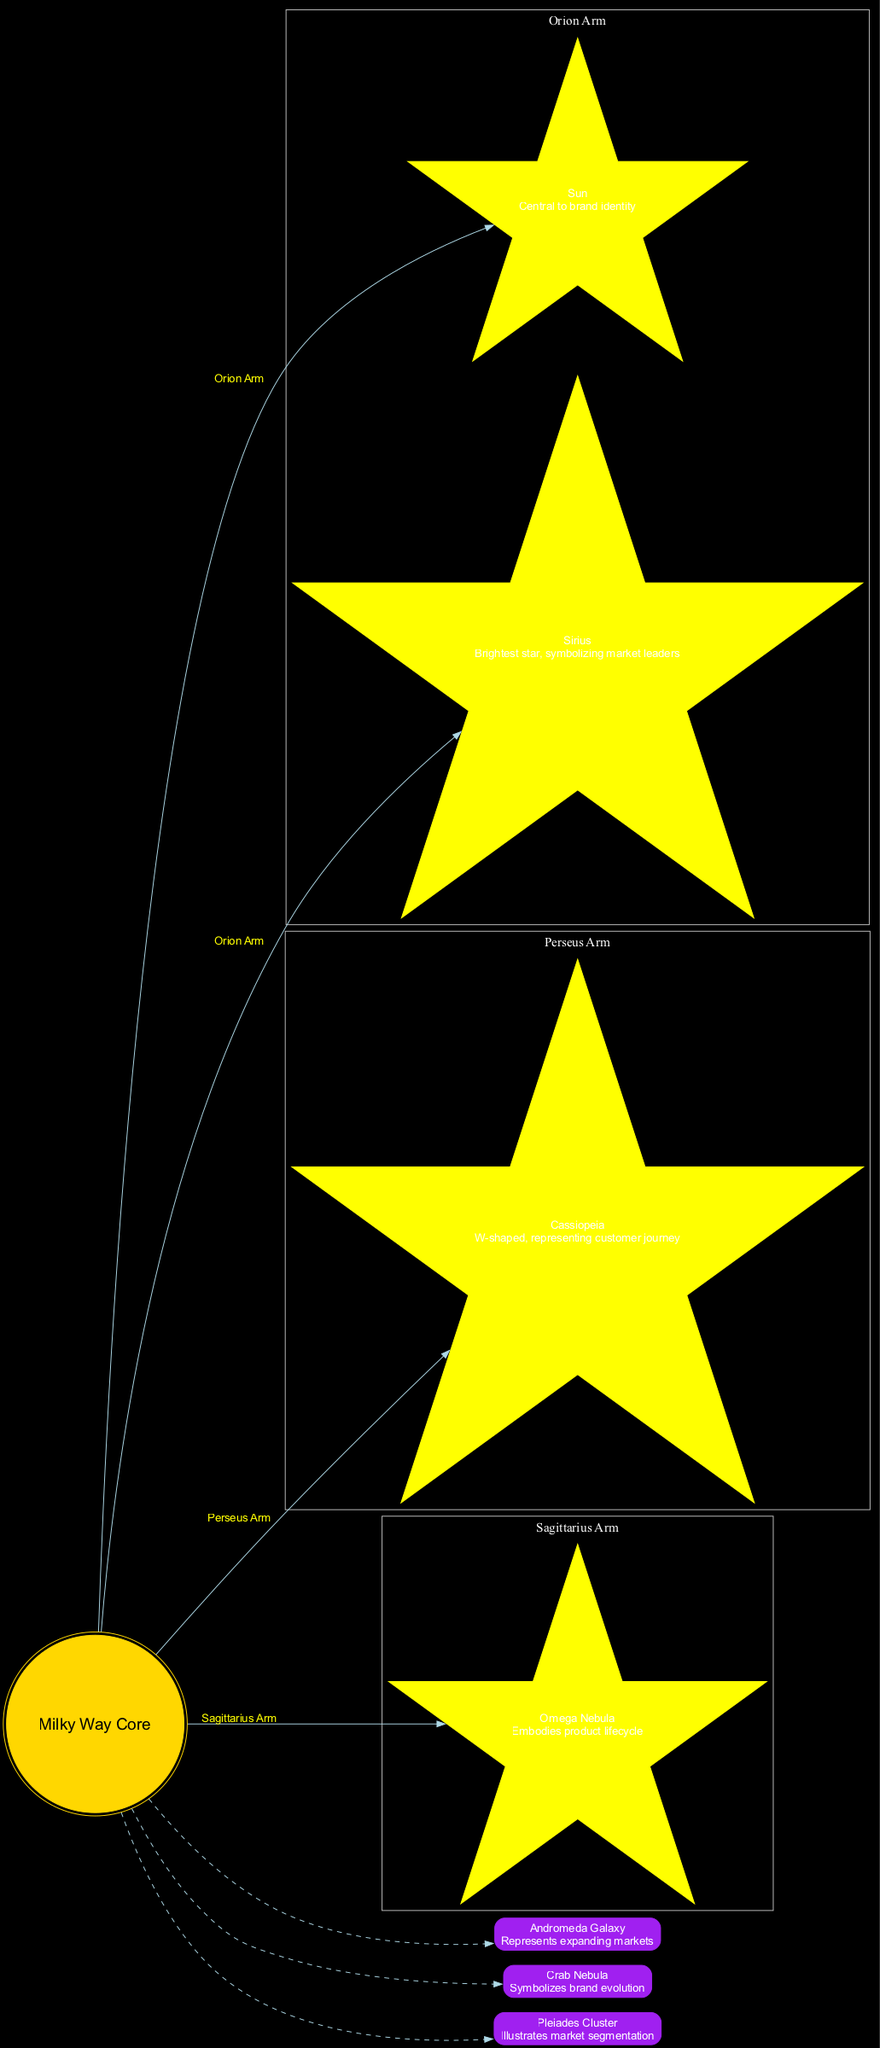What is at the center of the diagram? The diagram identifies "Milky Way Core" as the central node, explicitly labeled in a distinct style. This core serves as the focal point of the galaxy representation.
Answer: Milky Way Core How many arms does the Milky Way have in this diagram? The diagram includes three arms of the Milky Way: Orion Arm, Perseus Arm, and Sagittarius Arm. Counting these gives us a total of three arms represented.
Answer: 3 Which celestial object represents expanding markets? In the diagram, "Andromeda Galaxy" is specifically labeled with the description of representing expanding markets, making it the relevant celestial object for this concept.
Answer: Andromeda Galaxy What shape are the objects in the Orion Arm? The objects in the Orion Arm are shaped like stars, depicted as yellow stars in the diagram, indicating their importance within that specific arm.
Answer: star What does Cassiopeia represent in branding and marketing concepts? The diagram states that "Cassiopeia" represents the customer journey, providing important insight into how this constellation relates to marketing concepts.
Answer: customer journey Which arm contains the Omega Nebula? The Omega Nebula is located in the Sagittarius Arm, as indicated by the arm's name in the diagram. This relationship can be traced from the connection directly labeled from the arm to the object.
Answer: Sagittarius Arm How are the edges connecting the celestial objects styled? The edges connecting the celestial objects are styled with a dashed line in the diagram, which differentiates them from the solid lines connecting the galaxy arms to the core.
Answer: dashed What does the Crab Nebula symbolize? The description next to the "Crab Nebula" in the diagram states that it symbolizes brand evolution, providing a clear understanding of its significance within the context of marketing.
Answer: brand evolution How many major constellations are mentioned in the diagram? The diagram mentions one major constellation specifically linked to a branding concept, which is Cassiopeia in the Perseus Arm. This gives a total of one key constellation referenced directly.
Answer: 1 